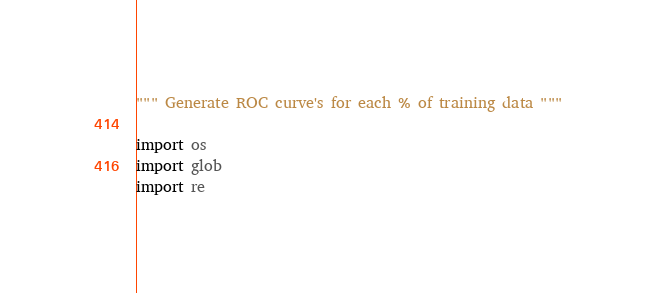<code> <loc_0><loc_0><loc_500><loc_500><_Python_>""" Generate ROC curve's for each % of training data """

import os
import glob
import re</code> 